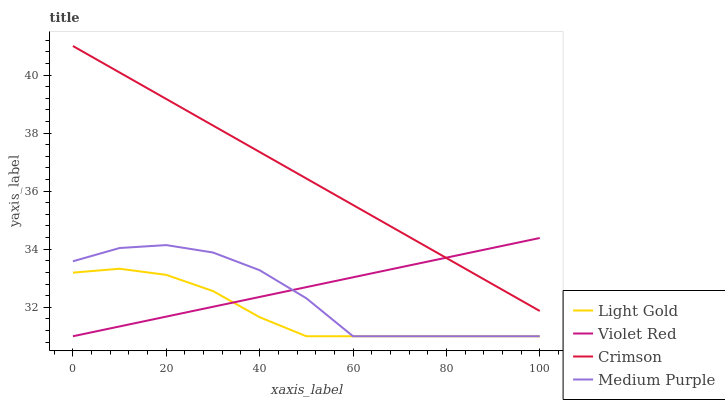Does Light Gold have the minimum area under the curve?
Answer yes or no. Yes. Does Crimson have the maximum area under the curve?
Answer yes or no. Yes. Does Medium Purple have the minimum area under the curve?
Answer yes or no. No. Does Medium Purple have the maximum area under the curve?
Answer yes or no. No. Is Crimson the smoothest?
Answer yes or no. Yes. Is Medium Purple the roughest?
Answer yes or no. Yes. Is Violet Red the smoothest?
Answer yes or no. No. Is Violet Red the roughest?
Answer yes or no. No. Does Medium Purple have the lowest value?
Answer yes or no. Yes. Does Crimson have the highest value?
Answer yes or no. Yes. Does Medium Purple have the highest value?
Answer yes or no. No. Is Medium Purple less than Crimson?
Answer yes or no. Yes. Is Crimson greater than Light Gold?
Answer yes or no. Yes. Does Medium Purple intersect Light Gold?
Answer yes or no. Yes. Is Medium Purple less than Light Gold?
Answer yes or no. No. Is Medium Purple greater than Light Gold?
Answer yes or no. No. Does Medium Purple intersect Crimson?
Answer yes or no. No. 